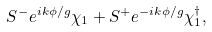Convert formula to latex. <formula><loc_0><loc_0><loc_500><loc_500>S ^ { - } e ^ { i k \phi / g } \chi _ { 1 } + S ^ { + } e ^ { - i k \phi / g } \chi _ { 1 } ^ { \dagger } ,</formula> 